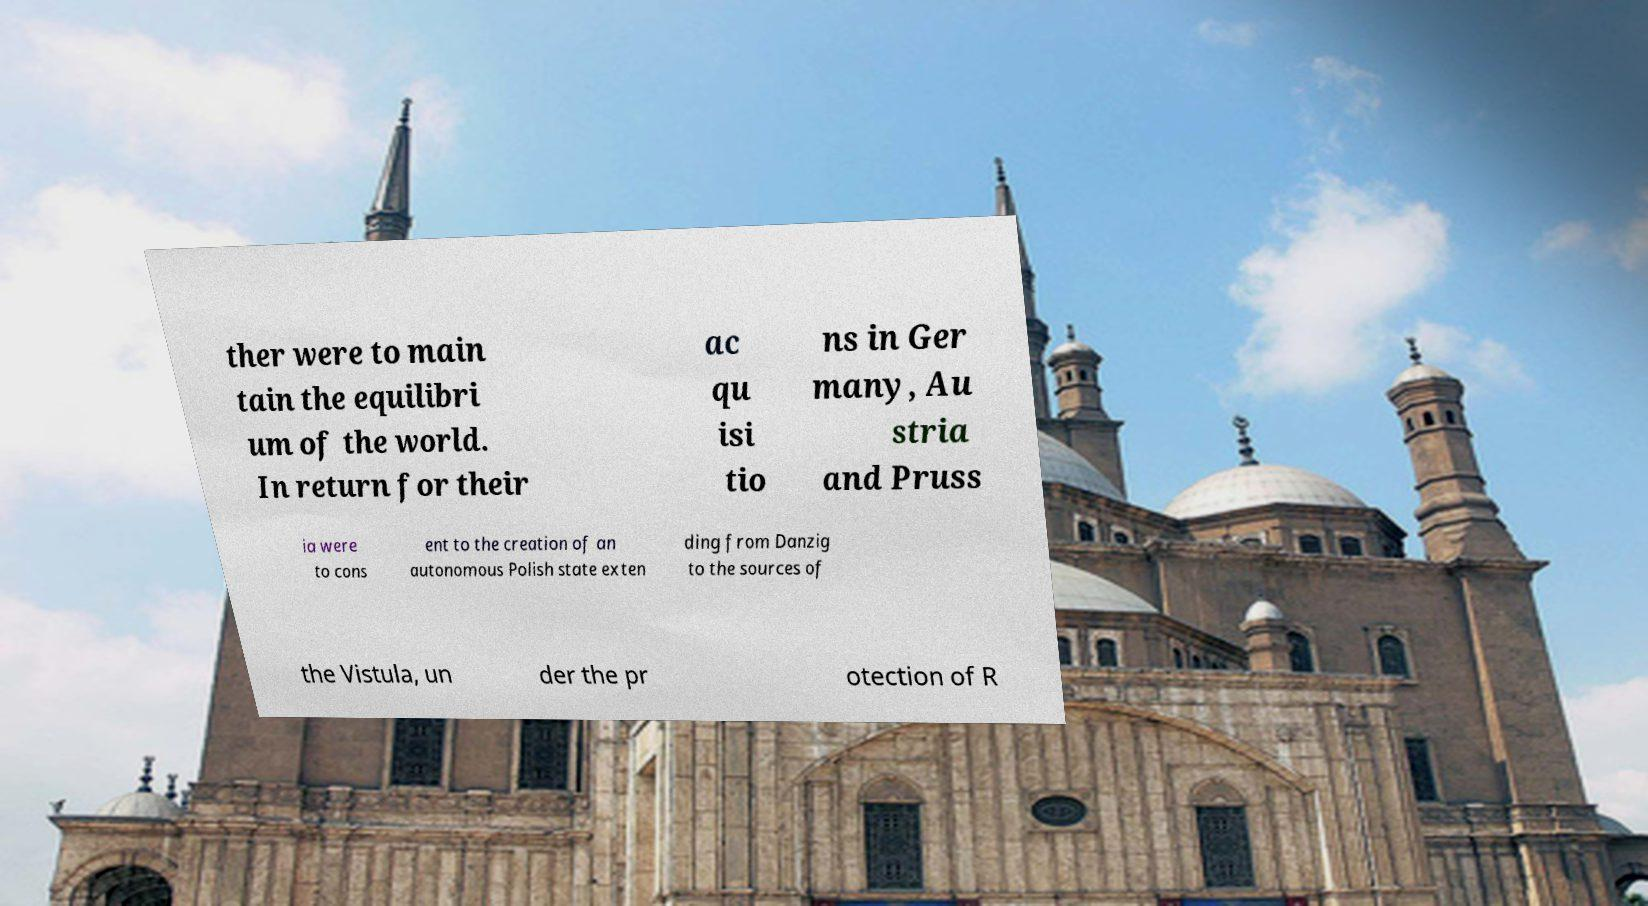Please read and relay the text visible in this image. What does it say? ther were to main tain the equilibri um of the world. In return for their ac qu isi tio ns in Ger many, Au stria and Pruss ia were to cons ent to the creation of an autonomous Polish state exten ding from Danzig to the sources of the Vistula, un der the pr otection of R 